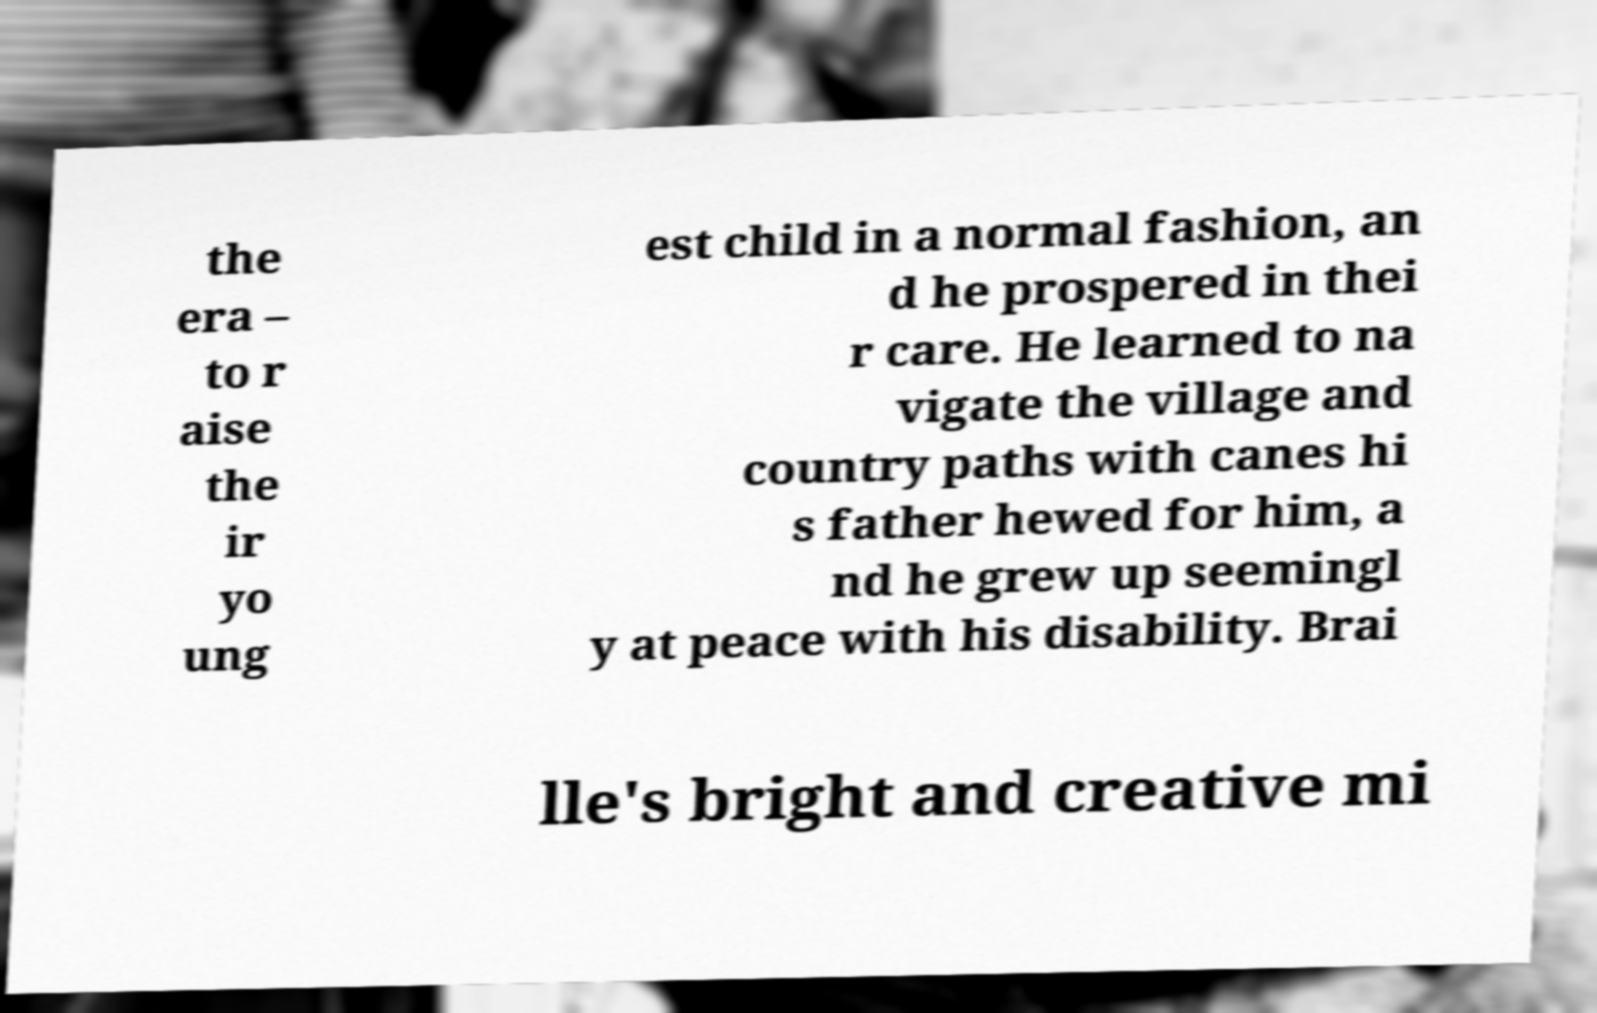Please read and relay the text visible in this image. What does it say? the era – to r aise the ir yo ung est child in a normal fashion, an d he prospered in thei r care. He learned to na vigate the village and country paths with canes hi s father hewed for him, a nd he grew up seemingl y at peace with his disability. Brai lle's bright and creative mi 